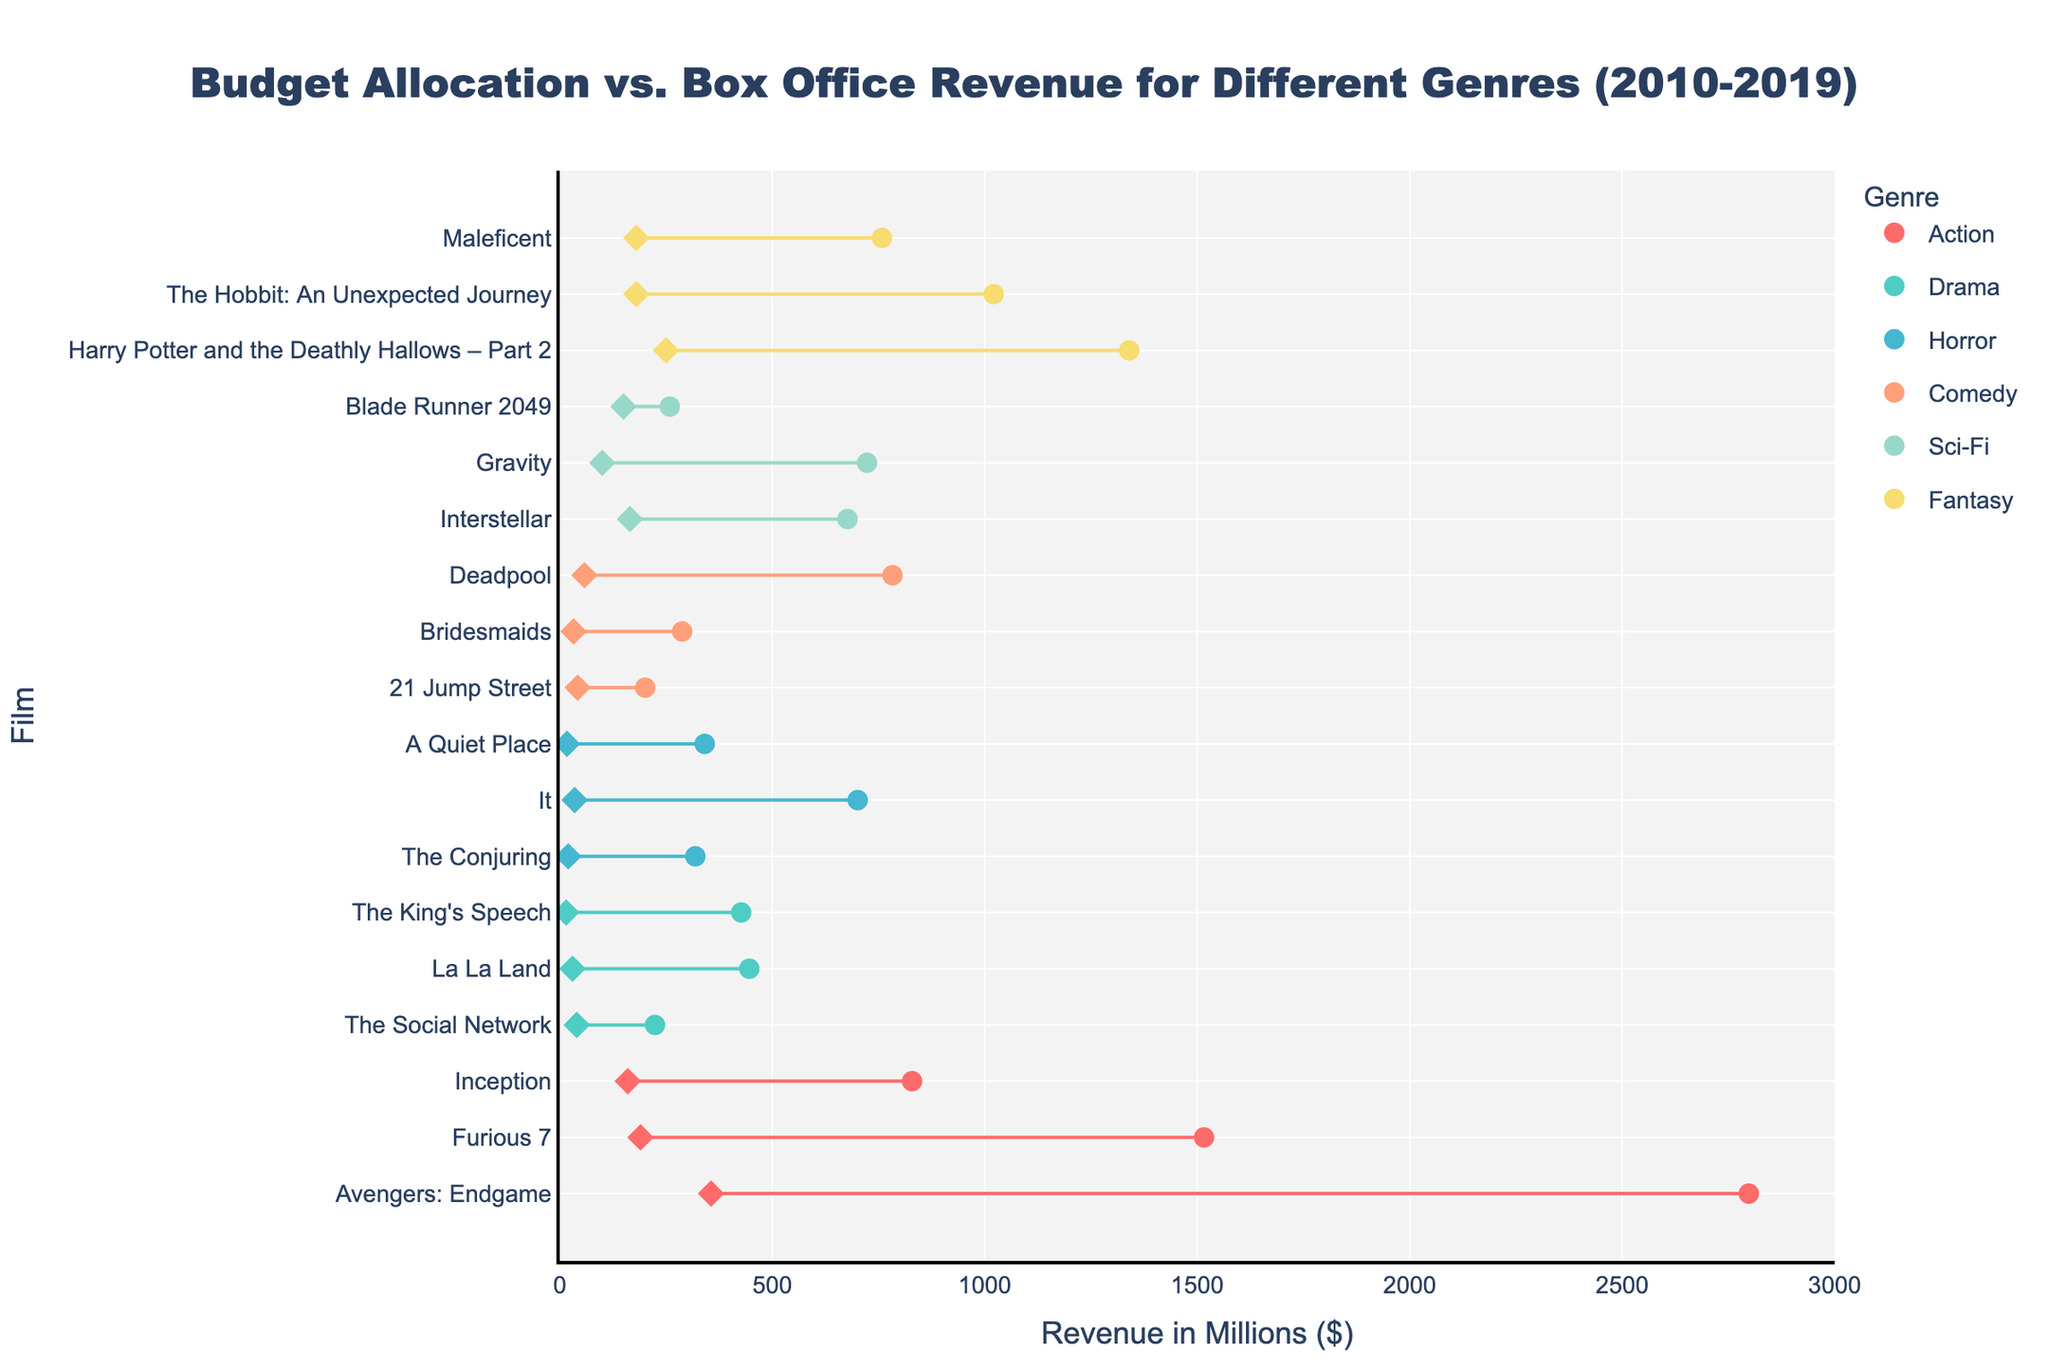What's the title of the figure? The title of the figure is usually found at the top of the chart. It provides an overview of what the chart is about. In this case, the title is "Budget Allocation vs. Box Office Revenue for Different Genres (2010-2019)."
Answer: Budget Allocation vs. Box Office Revenue for Different Genres (2010-2019) What is the x-axis representing in the figure? The x-axis of a chart is typically the horizontal line at the bottom. According to the description, the x-axis represents "Revenue in Millions ($)."
Answer: Revenue in Millions ($) Which film has the highest box office revenue, and in which genre? The highest box office revenue is the farthest point to the right. In this figure, "Avengers: Endgame" has the highest box office revenue in the Action genre.
Answer: Avengers: Endgame, Action How many different genres are represented in the figure? The different genres can be identified by their distinct colors or legends. According to the description of genres and colors, there are six unique genres.
Answer: Six Which film in the horror genre had the smallest budget? To find the film with the smallest budget, look at the leftmost diamond marker within the Horror genre's color. "A Quiet Place" had the smallest budget among horror films.
Answer: A Quiet Place What is the difference in box office revenue between "Interstellar" and "Gravity"? Find the markers for "Interstellar" and "Gravity" on the x-axis, both in the Sci-Fi genre. Interstellar has a box office revenue of 677 ($M) and Gravity has 723 ($M). The difference is 723 - 677.
Answer: 46 ($M) Which genre, on average, has the highest budget for its films? Identify the budget values (diamond markers) for all films within each genre. Calculate the average budget for each genre and compare them. Action films have the highest average budget.
Answer: Action Compare the box office revenue of "Deadpool" with the budget of "The Hobbit: An Unexpected Journey". Which is higher, and by how much? "Deadpool" has a box office revenue of 783 ($M), while "The Hobbit: An Unexpected Journey" has a budget of 180 ($M). Comparing these values, 783 - 180 gives the difference.
Answer: Deadpool by 603 ($M) Which film in the drama genre achieved the highest box office revenue relative to its budget? Identify the films in the Drama genre and calculate the ratio of box office revenue to budget for each film. "The King's Speech" has the highest revenue-to-budget ratio in the Drama genre.
Answer: The King's Speech 